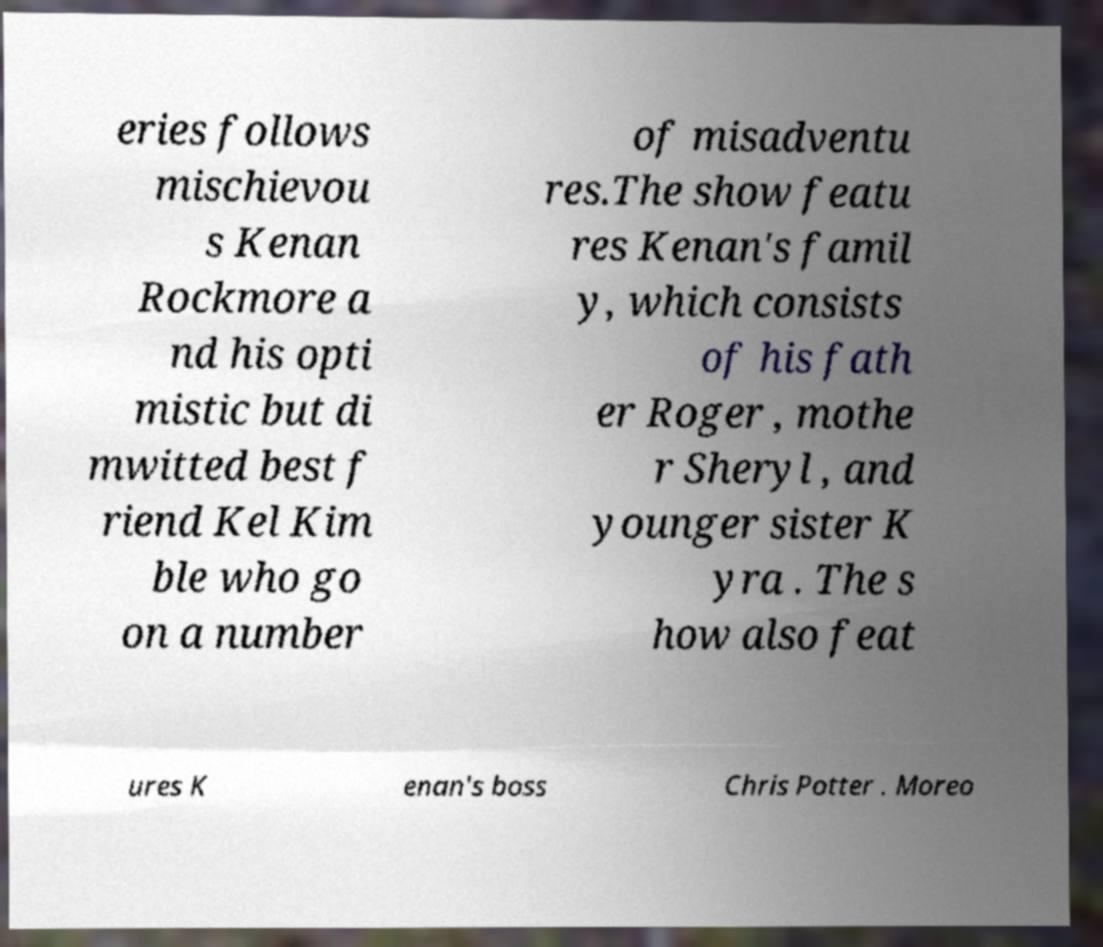Could you assist in decoding the text presented in this image and type it out clearly? eries follows mischievou s Kenan Rockmore a nd his opti mistic but di mwitted best f riend Kel Kim ble who go on a number of misadventu res.The show featu res Kenan's famil y, which consists of his fath er Roger , mothe r Sheryl , and younger sister K yra . The s how also feat ures K enan's boss Chris Potter . Moreo 